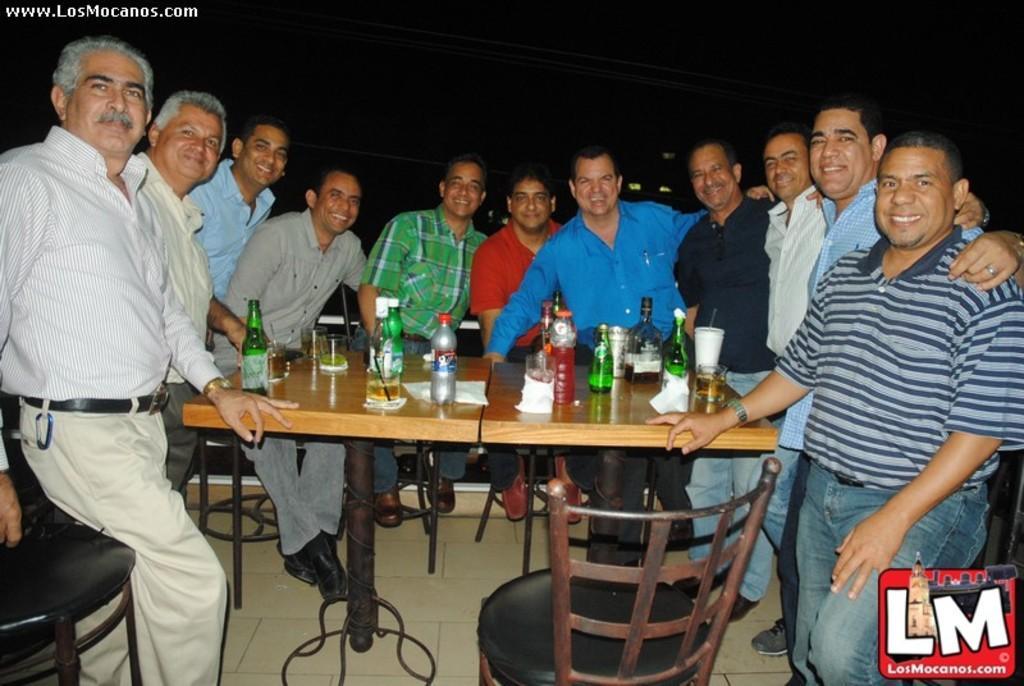Describe this image in one or two sentences. In this image there are group of people standing. On the there is a glass,bottle,tissues. 